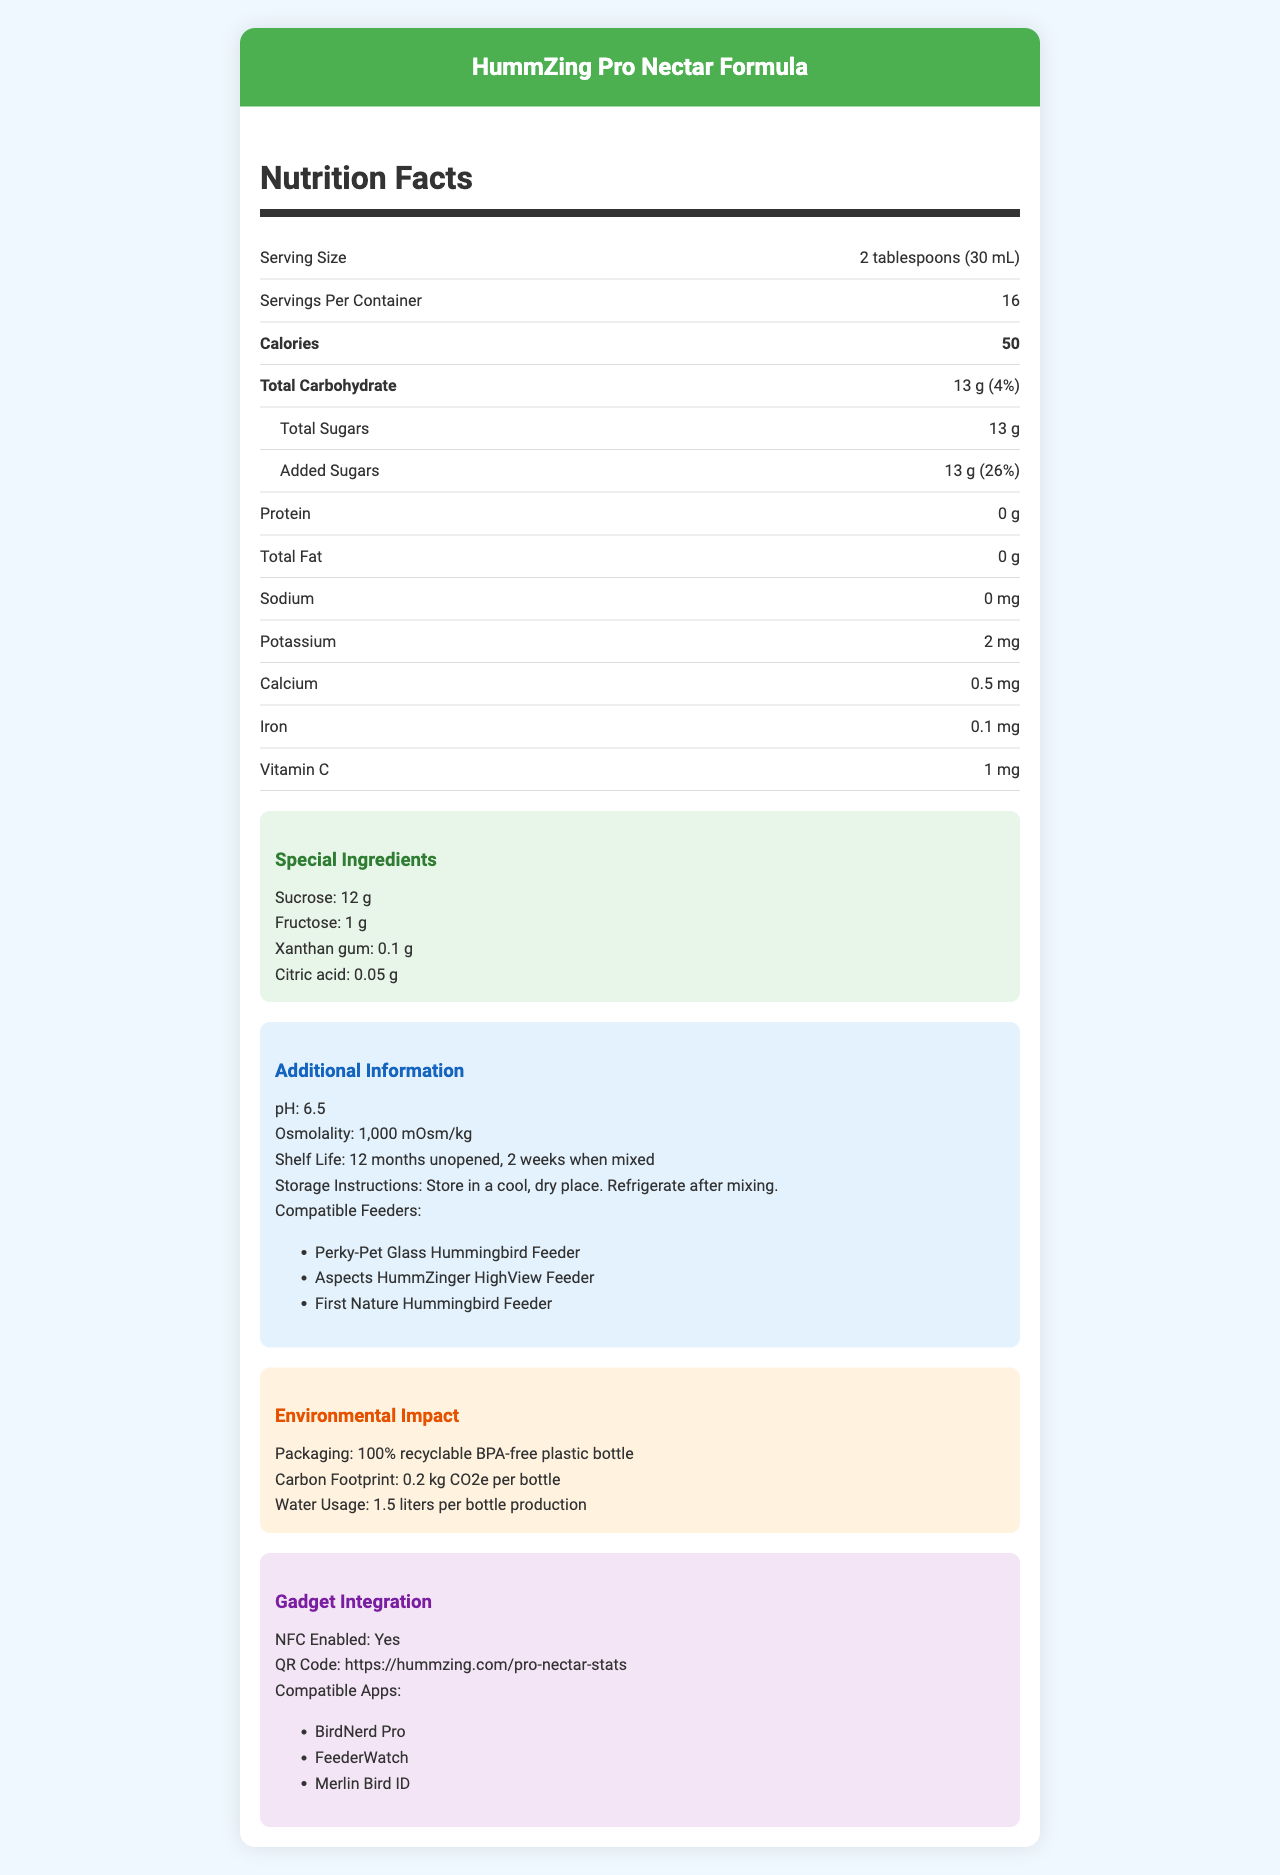what is the serving size of the HummZing Pro Nectar Formula? The document lists the serving size as "2 tablespoons (30 mL)".
Answer: 2 tablespoons (30 mL) how many servings per container are there? The document specifies that there are 16 servings per container.
Answer: 16 how many calories are there per serving? The document states that there are 50 calories per serving.
Answer: 50 how much sucrose is in the nectar formula? The document mentions in the "Special Ingredients" section that the amount of sucrose is 12 grams.
Answer: 12 g what is the shelf life of the nectar formula when unopened? The document lists the shelf life as "12 months unopened" under the "Additional Information" section.
Answer: 12 months which compatible feeder is NOT listed in the document? A. Perky-Pet Glass Hummingbird Feeder B. Aspects HummZinger HighView Feeder C. Harris Hummingbird Feeder The document lists the Perky-Pet, Aspects HummZinger, and First Nature feeders, but not the Harris Hummingbird Feeder.
Answer: C what is the osmolality of the nectar formula? A. 500 mOsm/kg B. 1,000 mOsm/kg C. 750 mOsm/kg The osmolality is listed as "1,000 mOsm/kg" in the "Additional Information" section.
Answer: B is the packaging 100% recyclable? The "Environmental Impact" section states that the packaging is made from "100% recyclable BPA-free plastic".
Answer: Yes what is the carbon footprint per bottle? The document mentions the carbon footprint as "0.2 kg CO2e per bottle" under the "Environmental Impact" section.
Answer: 0.2 kg CO2e per bottle describe the main idea of the document The document is focused on presenting comprehensive details about the HummZing Pro Nectar Formula, encompassing nutritional facts, special components, how to store and use the product, its environmental considerations, and compatibility with various gadgets and apps.
Answer: The document provides detailed nutritional information about the HummZing Pro Nectar Formula, including serving size, calories, and specific nutrient quantities. It also lists special ingredients, additional instructions for use and storage, environmental impact, and gadget integration details. what is the total fat content per serving? The document lists "Total Fat" as 0 grams in the nutrition facts section.
Answer: 0 g how much added sugar is in each serving? The document specifies that there are 13 grams of added sugars per serving, which is 26% of the daily value.
Answer: 13 g is the nectar formula nfc enabled? The "Gadget Integration" section of the document states that the nectar formula is NFC enabled.
Answer: Yes who is the manufacturer of the HummZing Pro Nectar Formula? The document does not provide information about the manufacturer.
Answer: Cannot be determined what type of acid is used in the nectar formula? The "Special Ingredients" section lists citric acid as one of the ingredients.
Answer: Citric acid what are some of the compatible apps listed for gadget integration? The "Gadget Integration" section lists BirdNerd Pro, FeederWatch, and Merlin Bird ID as the compatible apps.
Answer: BirdNerd Pro, FeederWatch, Merlin Bird ID 